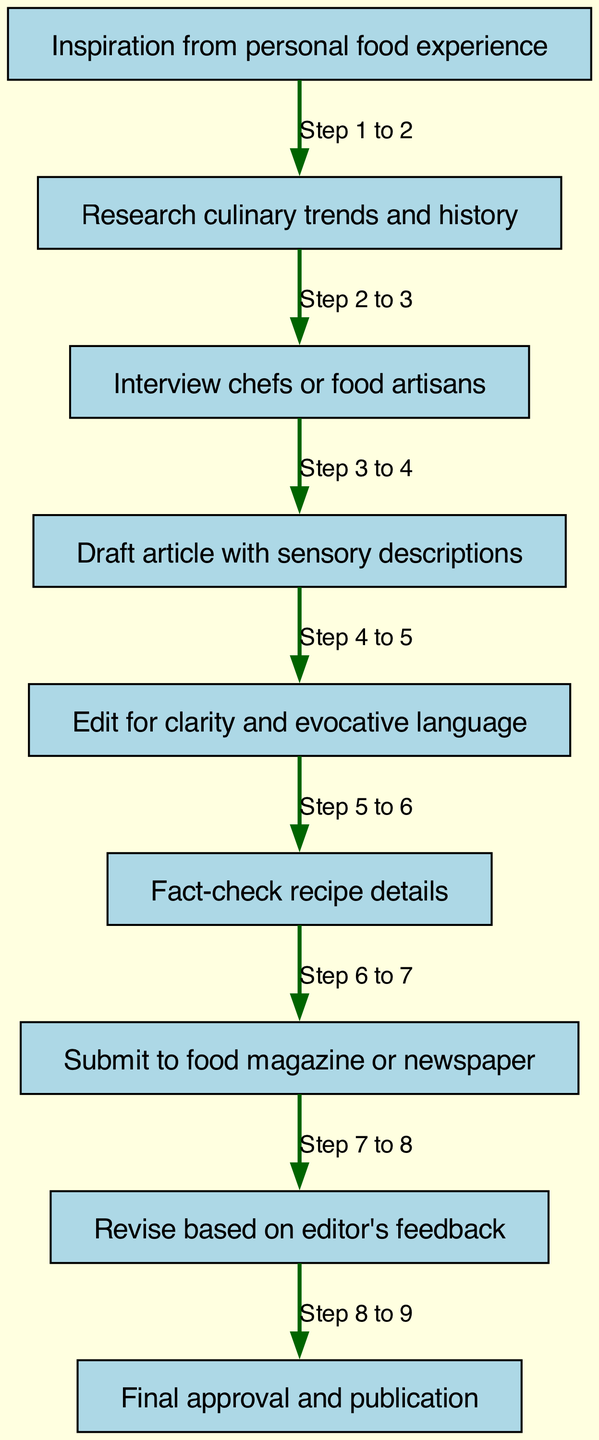What is the first step for a food writer? The first step in the diagram is "Inspiration from personal food experience". This is indicated as the starting point of the flow chart.
Answer: Inspiration from personal food experience How many nodes are present in the diagram? The diagram consists of a total of 9 nodes, each representing a step in the food writing journey.
Answer: 9 What follows the drafting of the article? After the step "Draft article with sensory descriptions", the next step is "Edit for clarity and evocative language" which indicates the editing process that comes after drafting.
Answer: Edit for clarity and evocative language What stage involves interviewing chefs? The stage where chefs or food artisans are interviewed is directly after the "Research culinary trends and history" step and before drafting the article.
Answer: Interview chefs or food artisans What action is taken after submitting the article? Post-submission, the action that follows is "Revise based on editor's feedback" which shows the iterative process between submission and revision.
Answer: Revise based on editor's feedback Which step is indicated as the final step in the journey? The final step in the diagram is "Final approval and publication", marking the end of the food writing process.
Answer: Final approval and publication What process comes before fact-checking recipe details? Before the "Fact-check recipe details", the step is "Edit for clarity and evocative language", showcasing the need to edit before finalizing factual information.
Answer: Edit for clarity and evocative language How many steps are there in total from inspiration to publication? The total steps outlined in the journey from inspiration to publication are 8 steps, each leading sequentially to the final approval.
Answer: 8 What is the relationship between editing and final approval? The relationship is that "Edit for clarity and evocative language" comes before "Final approval and publication", indicating editing must be completed prior to final approval of the article.
Answer: Edit for clarity and evocative language to Final approval and publication 